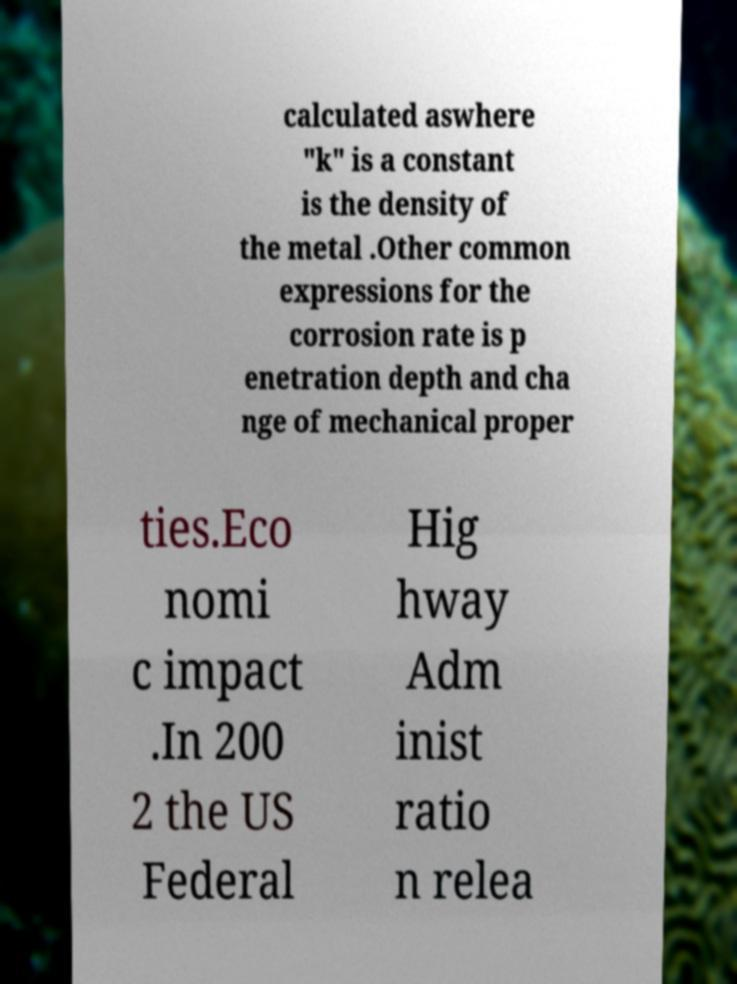Please read and relay the text visible in this image. What does it say? calculated aswhere "k" is a constant is the density of the metal .Other common expressions for the corrosion rate is p enetration depth and cha nge of mechanical proper ties.Eco nomi c impact .In 200 2 the US Federal Hig hway Adm inist ratio n relea 